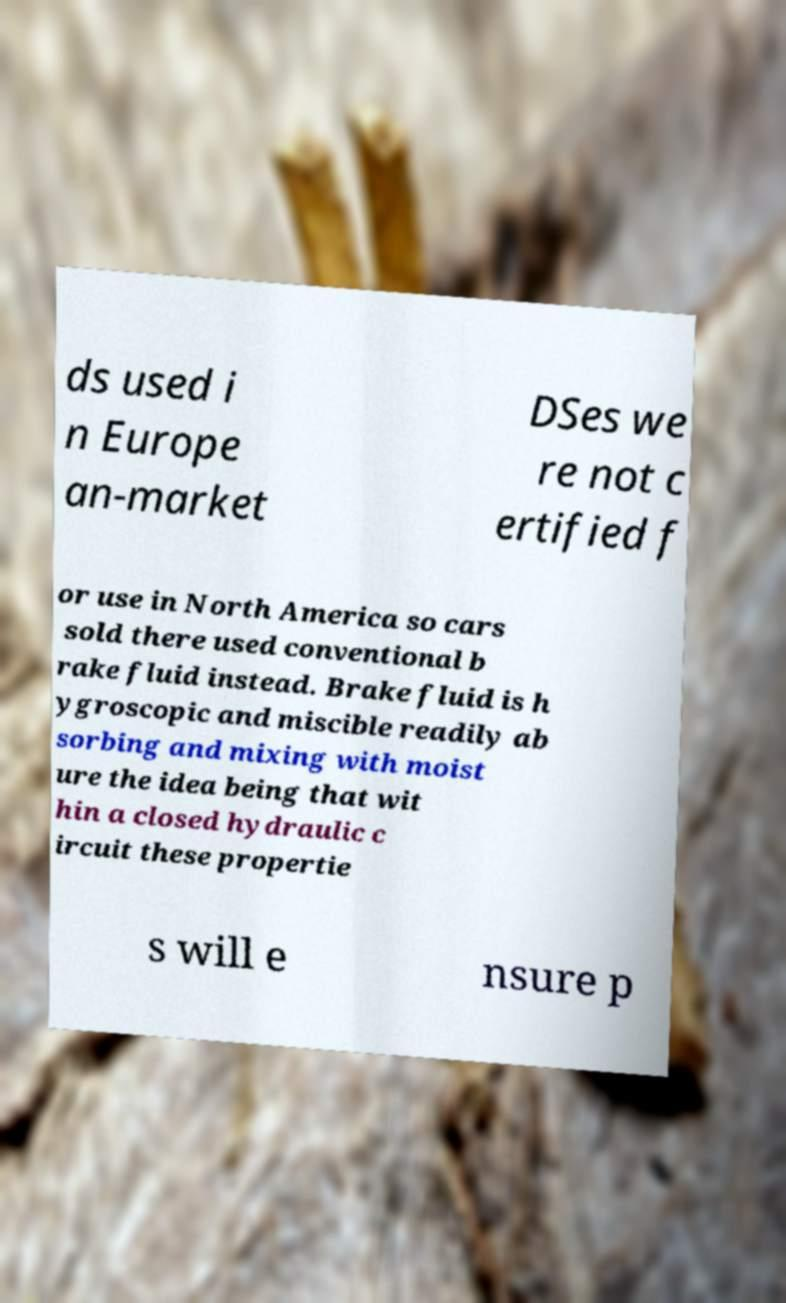There's text embedded in this image that I need extracted. Can you transcribe it verbatim? ds used i n Europe an-market DSes we re not c ertified f or use in North America so cars sold there used conventional b rake fluid instead. Brake fluid is h ygroscopic and miscible readily ab sorbing and mixing with moist ure the idea being that wit hin a closed hydraulic c ircuit these propertie s will e nsure p 